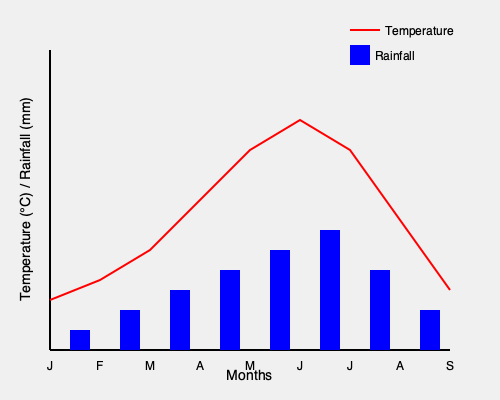Based on the climate graph for a tropical destination, which month would be the best time to visit if you want to avoid heavy rainfall and enjoy moderate temperatures? To determine the best month to visit, we need to analyze both temperature and rainfall patterns:

1. Temperature analysis:
   - The red line represents temperature throughout the year.
   - The lowest temperatures are around January-February.
   - The highest temperatures are around May-June.
   - Moderate temperatures are seen in March-April and July-August.

2. Rainfall analysis:
   - The blue bars represent rainfall amounts.
   - The driest months are January and February.
   - The wettest months are May, June, and July.
   - Moderate rainfall occurs in March, April, August, and September.

3. Balancing temperature and rainfall:
   - We want to avoid heavy rainfall (eliminating May, June, and July).
   - We also want moderate temperatures (eliminating January and February).
   - This leaves us with March, April, August, and September as potential options.

4. Optimal choice:
   - Among these options, April has slightly less rainfall than March.
   - April also has more moderate temperatures compared to August and September.

Therefore, April provides the best balance of moderate temperatures and lower rainfall, making it the optimal month for visiting this tropical destination.
Answer: April 